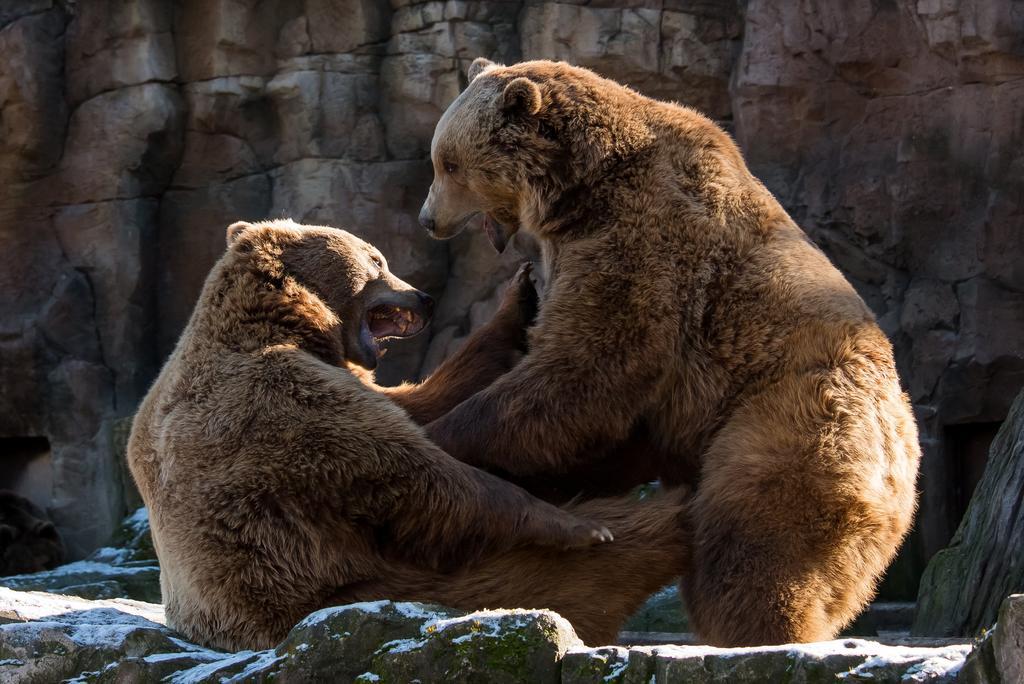Describe this image in one or two sentences. In this image we can see two bears on the surface. We can also see some stones and the rock. 